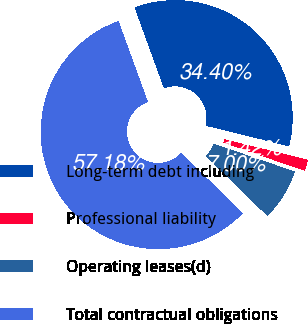Convert chart to OTSL. <chart><loc_0><loc_0><loc_500><loc_500><pie_chart><fcel>Long-term debt including<fcel>Professional liability<fcel>Operating leases(d)<fcel>Total contractual obligations<nl><fcel>34.4%<fcel>1.42%<fcel>7.0%<fcel>57.18%<nl></chart> 